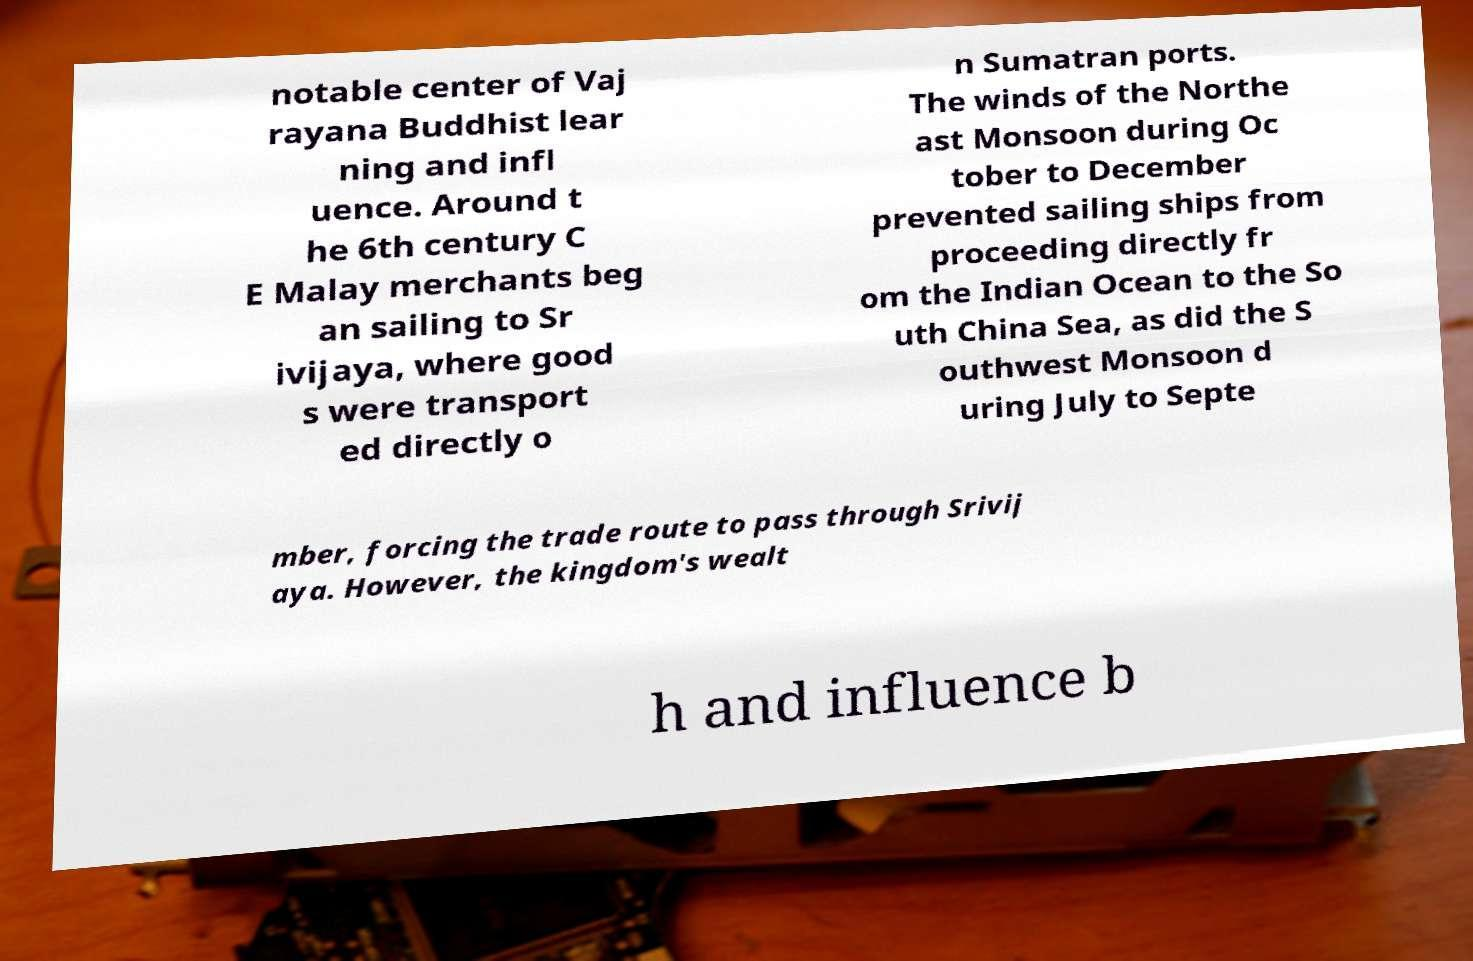For documentation purposes, I need the text within this image transcribed. Could you provide that? notable center of Vaj rayana Buddhist lear ning and infl uence. Around t he 6th century C E Malay merchants beg an sailing to Sr ivijaya, where good s were transport ed directly o n Sumatran ports. The winds of the Northe ast Monsoon during Oc tober to December prevented sailing ships from proceeding directly fr om the Indian Ocean to the So uth China Sea, as did the S outhwest Monsoon d uring July to Septe mber, forcing the trade route to pass through Srivij aya. However, the kingdom's wealt h and influence b 